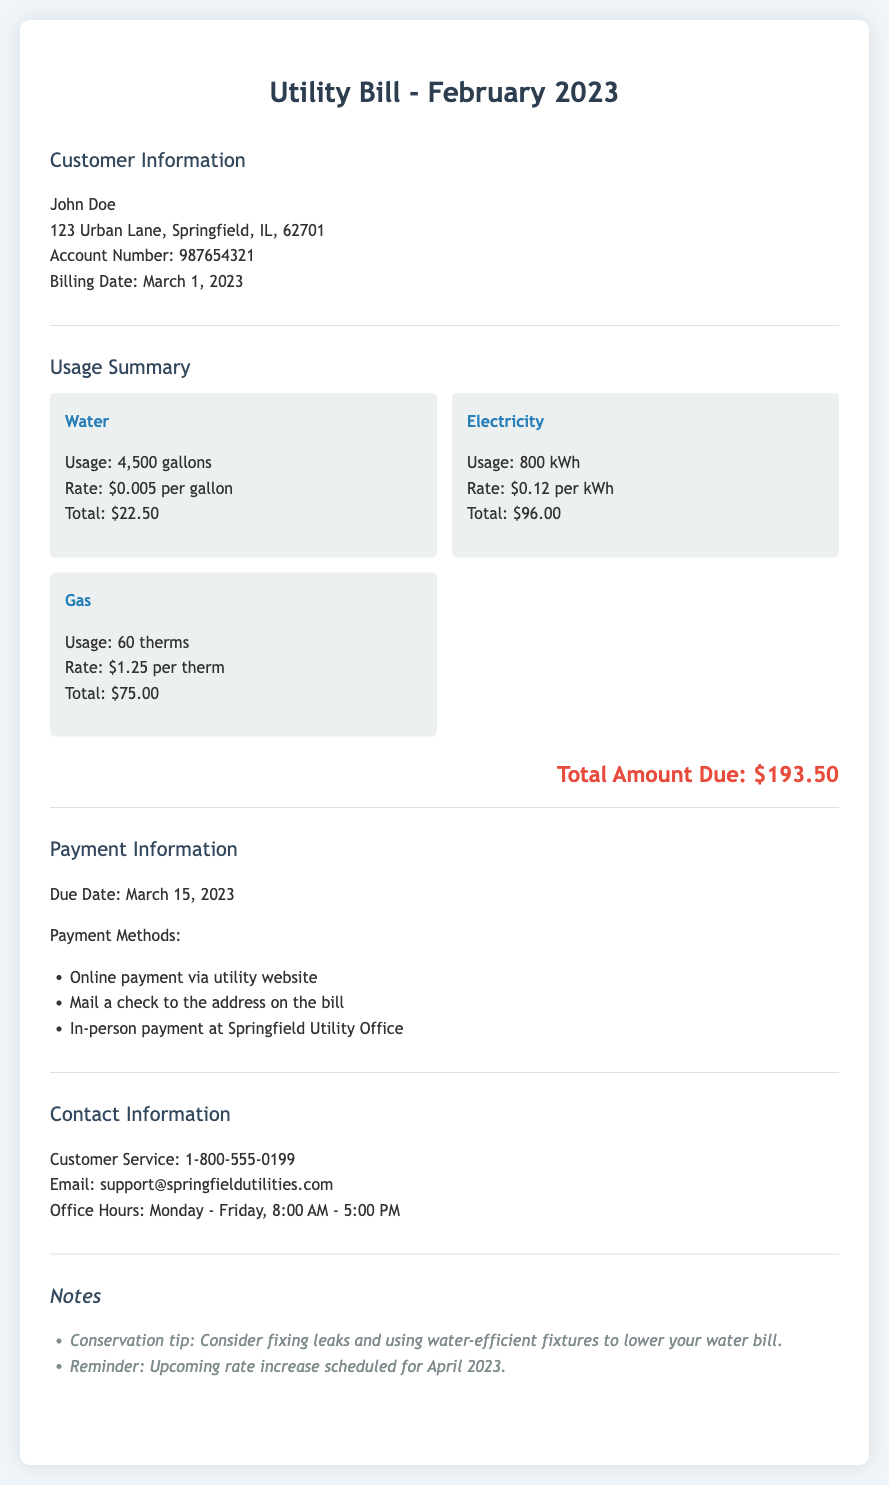what is the total amount due? The total amount due is stated at the end of the usage summary section, which is $193.50.
Answer: $193.50 what is the usage of electricity in kWh? The usage of electricity is found in the usage summary section, which states 800 kWh.
Answer: 800 kWh who is the customer? The customer's name is mentioned at the top under customer information, which is John Doe.
Answer: John Doe what is the rate per therm for gas usage? The rate for gas usage is listed under the gas section of the usage summary, which is $1.25 per therm.
Answer: $1.25 per therm when is the payment due date? The payment due date is indicated in the payment information section, which is March 15, 2023.
Answer: March 15, 2023 how many gallons of water were used? The total water usage is provided in the usage summary, which is 4,500 gallons.
Answer: 4,500 gallons what is the customer service phone number? The customer service phone number is provided in the contact information section, which is 1-800-555-0199.
Answer: 1-800-555-0199 what conservation tip is mentioned in the notes? The conservation tip is stated in the notes section, which suggests fixing leaks and using water-efficient fixtures.
Answer: Fixing leaks and using water-efficient fixtures what is the rate for electricity usage? The rate for electricity usage is highlighted in the usage summary section, which is $0.12 per kWh.
Answer: $0.12 per kWh 